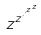Convert formula to latex. <formula><loc_0><loc_0><loc_500><loc_500>z ^ { z ^ { \cdot ^ { \cdot ^ { z ^ { z } } } } }</formula> 